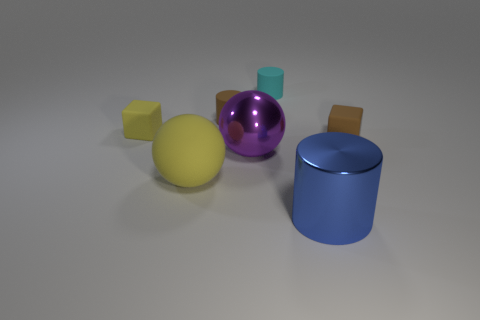Subtract all matte cylinders. How many cylinders are left? 1 Subtract all brown cylinders. How many cylinders are left? 2 Subtract all cubes. How many objects are left? 5 Subtract 3 cylinders. How many cylinders are left? 0 Subtract all cyan cylinders. How many yellow cubes are left? 1 Subtract all yellow cubes. Subtract all cyan spheres. How many cubes are left? 1 Subtract all small green rubber cylinders. Subtract all shiny cylinders. How many objects are left? 6 Add 1 blue cylinders. How many blue cylinders are left? 2 Add 6 cyan objects. How many cyan objects exist? 7 Add 1 small yellow cubes. How many objects exist? 8 